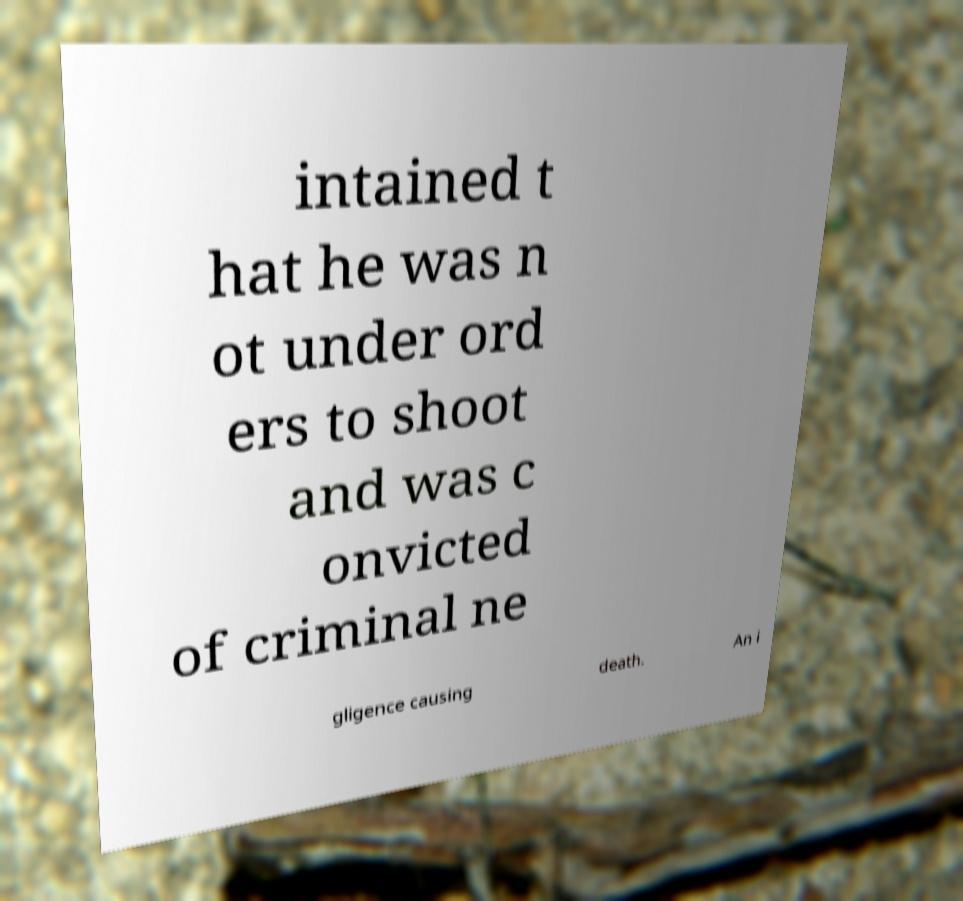Could you assist in decoding the text presented in this image and type it out clearly? intained t hat he was n ot under ord ers to shoot and was c onvicted of criminal ne gligence causing death. An i 